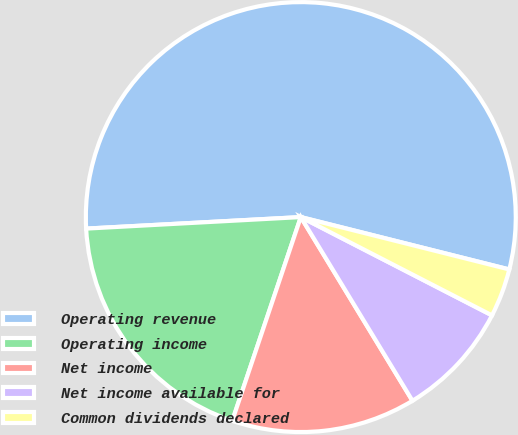<chart> <loc_0><loc_0><loc_500><loc_500><pie_chart><fcel>Operating revenue<fcel>Operating income<fcel>Net income<fcel>Net income available for<fcel>Common dividends declared<nl><fcel>54.77%<fcel>18.98%<fcel>13.86%<fcel>8.75%<fcel>3.64%<nl></chart> 